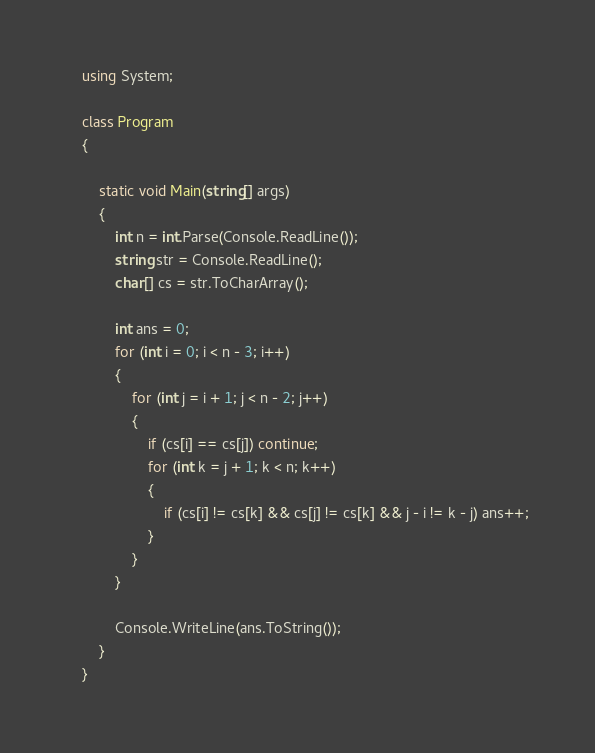<code> <loc_0><loc_0><loc_500><loc_500><_C#_>
    using System;

    class Program
    {

        static void Main(string[] args)
        {
            int n = int.Parse(Console.ReadLine());
            string str = Console.ReadLine();
            char[] cs = str.ToCharArray();

            int ans = 0;
            for (int i = 0; i < n - 3; i++)
            {
                for (int j = i + 1; j < n - 2; j++)
                {
                    if (cs[i] == cs[j]) continue;
                    for (int k = j + 1; k < n; k++)
                    {
                        if (cs[i] != cs[k] && cs[j] != cs[k] && j - i != k - j) ans++;
                    }
                }
            }

            Console.WriteLine(ans.ToString());
        }
    }</code> 